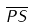<formula> <loc_0><loc_0><loc_500><loc_500>\overline { P S }</formula> 